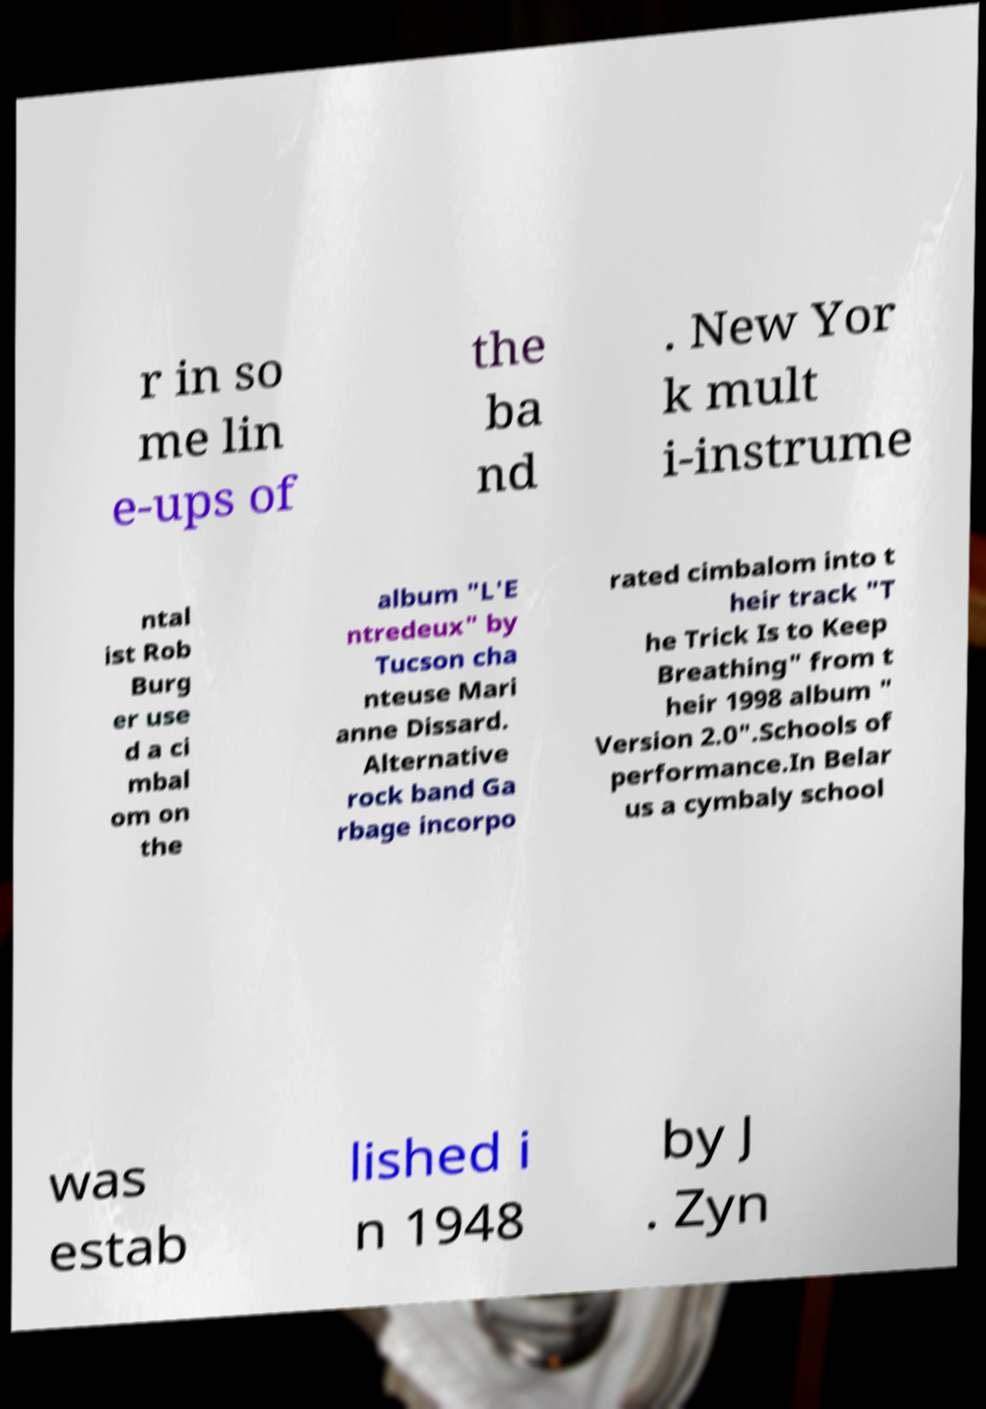Please identify and transcribe the text found in this image. r in so me lin e-ups of the ba nd . New Yor k mult i-instrume ntal ist Rob Burg er use d a ci mbal om on the album "L'E ntredeux" by Tucson cha nteuse Mari anne Dissard. Alternative rock band Ga rbage incorpo rated cimbalom into t heir track "T he Trick Is to Keep Breathing" from t heir 1998 album " Version 2.0".Schools of performance.In Belar us a cymbaly school was estab lished i n 1948 by J . Zyn 